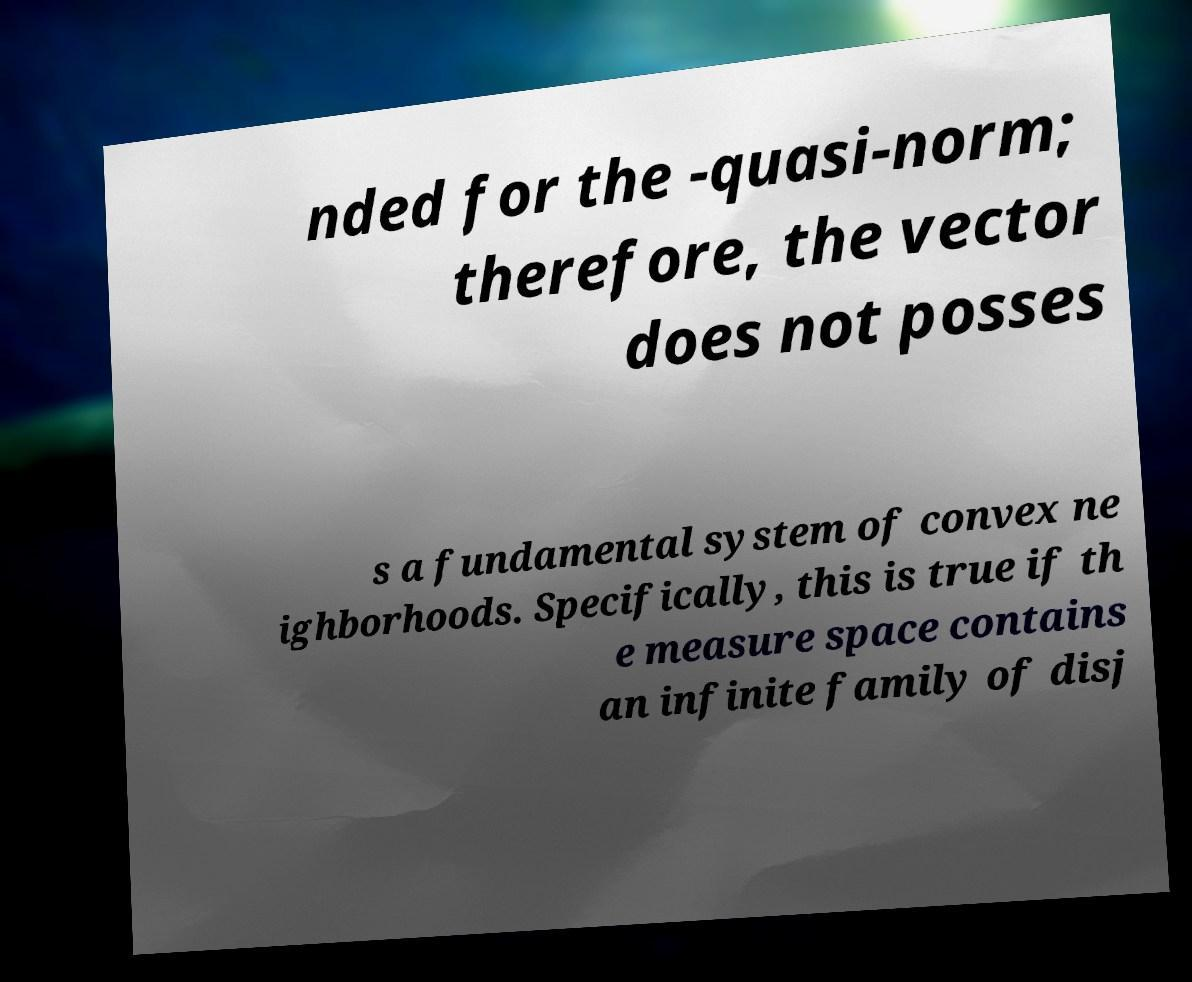Can you read and provide the text displayed in the image?This photo seems to have some interesting text. Can you extract and type it out for me? nded for the -quasi-norm; therefore, the vector does not posses s a fundamental system of convex ne ighborhoods. Specifically, this is true if th e measure space contains an infinite family of disj 